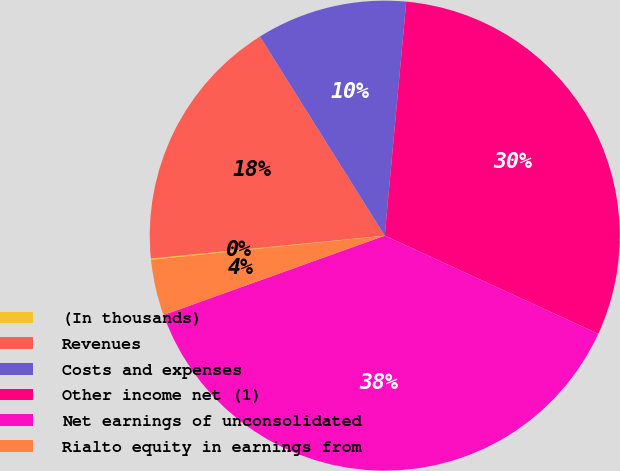Convert chart to OTSL. <chart><loc_0><loc_0><loc_500><loc_500><pie_chart><fcel>(In thousands)<fcel>Revenues<fcel>Costs and expenses<fcel>Other income net (1)<fcel>Net earnings of unconsolidated<fcel>Rialto equity in earnings from<nl><fcel>0.09%<fcel>17.64%<fcel>10.37%<fcel>30.4%<fcel>37.66%<fcel>3.84%<nl></chart> 